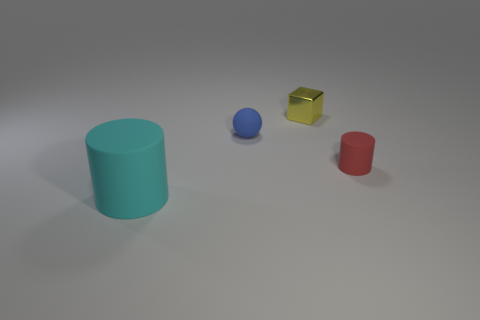Add 4 big yellow metallic spheres. How many objects exist? 8 Subtract 1 cubes. How many cubes are left? 0 Subtract all cyan cylinders. How many cylinders are left? 1 Subtract all cubes. How many objects are left? 3 Subtract all red balls. How many cyan cylinders are left? 1 Subtract 0 blue cylinders. How many objects are left? 4 Subtract all gray cylinders. Subtract all brown balls. How many cylinders are left? 2 Subtract all yellow things. Subtract all cyan shiny blocks. How many objects are left? 3 Add 3 shiny objects. How many shiny objects are left? 4 Add 1 red shiny spheres. How many red shiny spheres exist? 1 